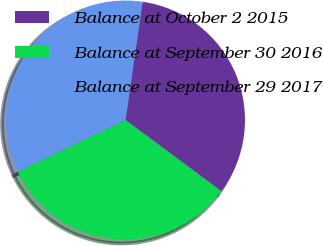Convert chart to OTSL. <chart><loc_0><loc_0><loc_500><loc_500><pie_chart><fcel>Balance at October 2 2015<fcel>Balance at September 30 2016<fcel>Balance at September 29 2017<nl><fcel>32.88%<fcel>32.71%<fcel>34.41%<nl></chart> 